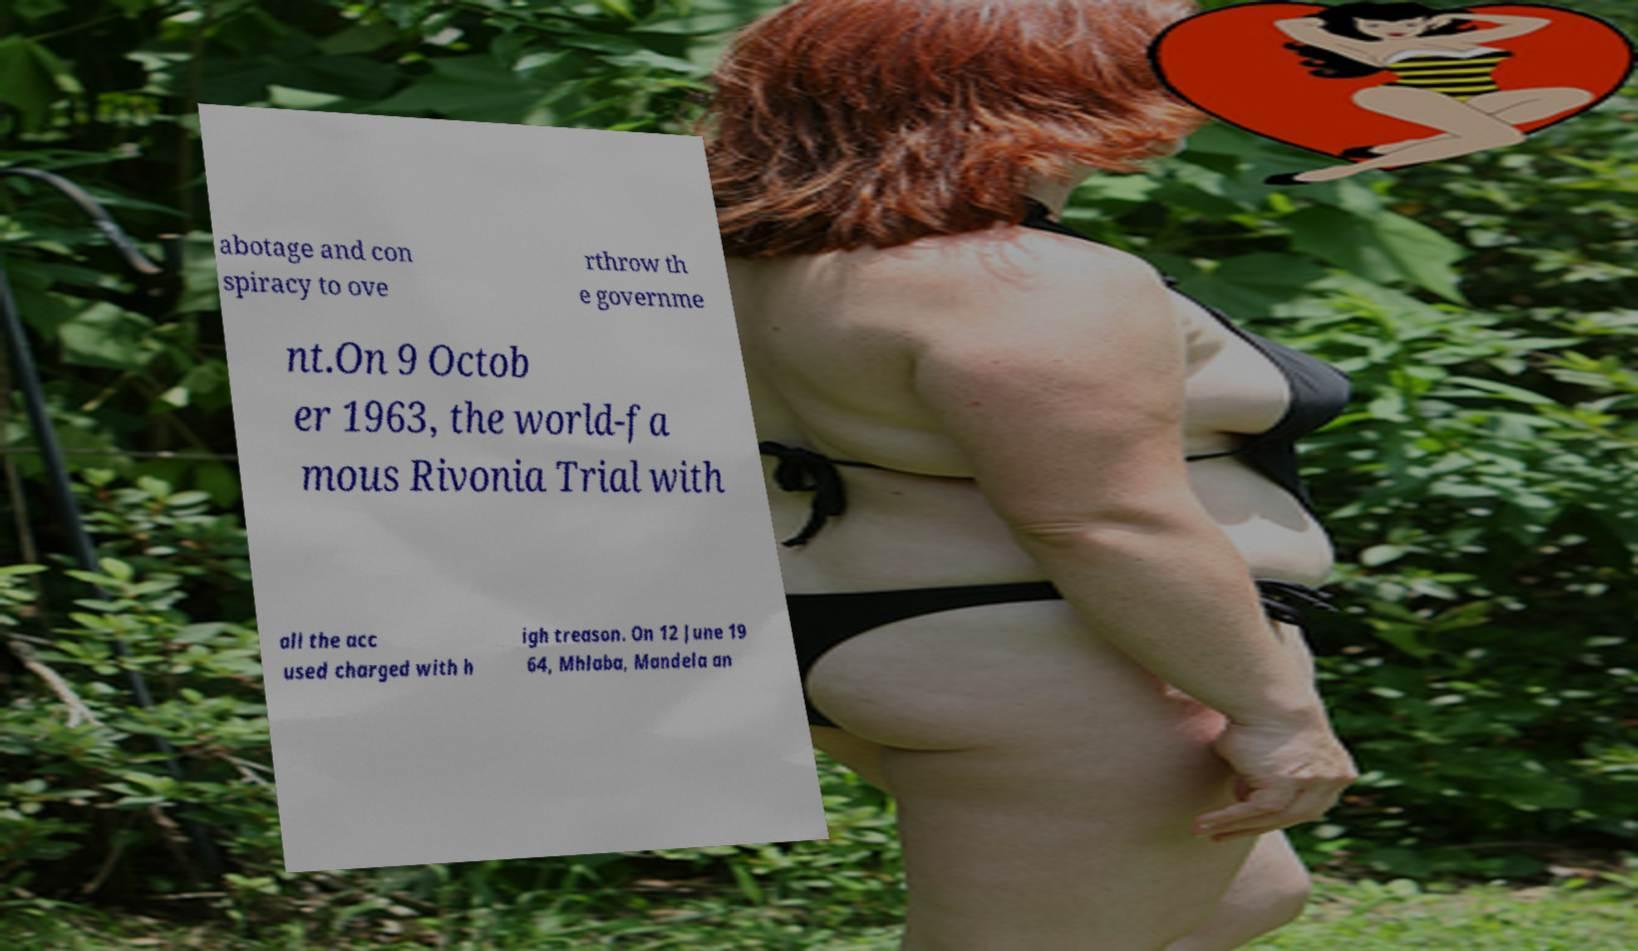Could you extract and type out the text from this image? abotage and con spiracy to ove rthrow th e governme nt.On 9 Octob er 1963, the world-fa mous Rivonia Trial with all the acc used charged with h igh treason. On 12 June 19 64, Mhlaba, Mandela an 